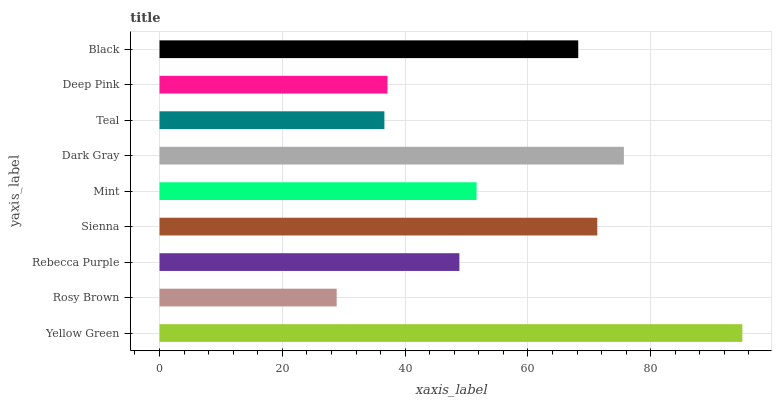Is Rosy Brown the minimum?
Answer yes or no. Yes. Is Yellow Green the maximum?
Answer yes or no. Yes. Is Rebecca Purple the minimum?
Answer yes or no. No. Is Rebecca Purple the maximum?
Answer yes or no. No. Is Rebecca Purple greater than Rosy Brown?
Answer yes or no. Yes. Is Rosy Brown less than Rebecca Purple?
Answer yes or no. Yes. Is Rosy Brown greater than Rebecca Purple?
Answer yes or no. No. Is Rebecca Purple less than Rosy Brown?
Answer yes or no. No. Is Mint the high median?
Answer yes or no. Yes. Is Mint the low median?
Answer yes or no. Yes. Is Black the high median?
Answer yes or no. No. Is Black the low median?
Answer yes or no. No. 